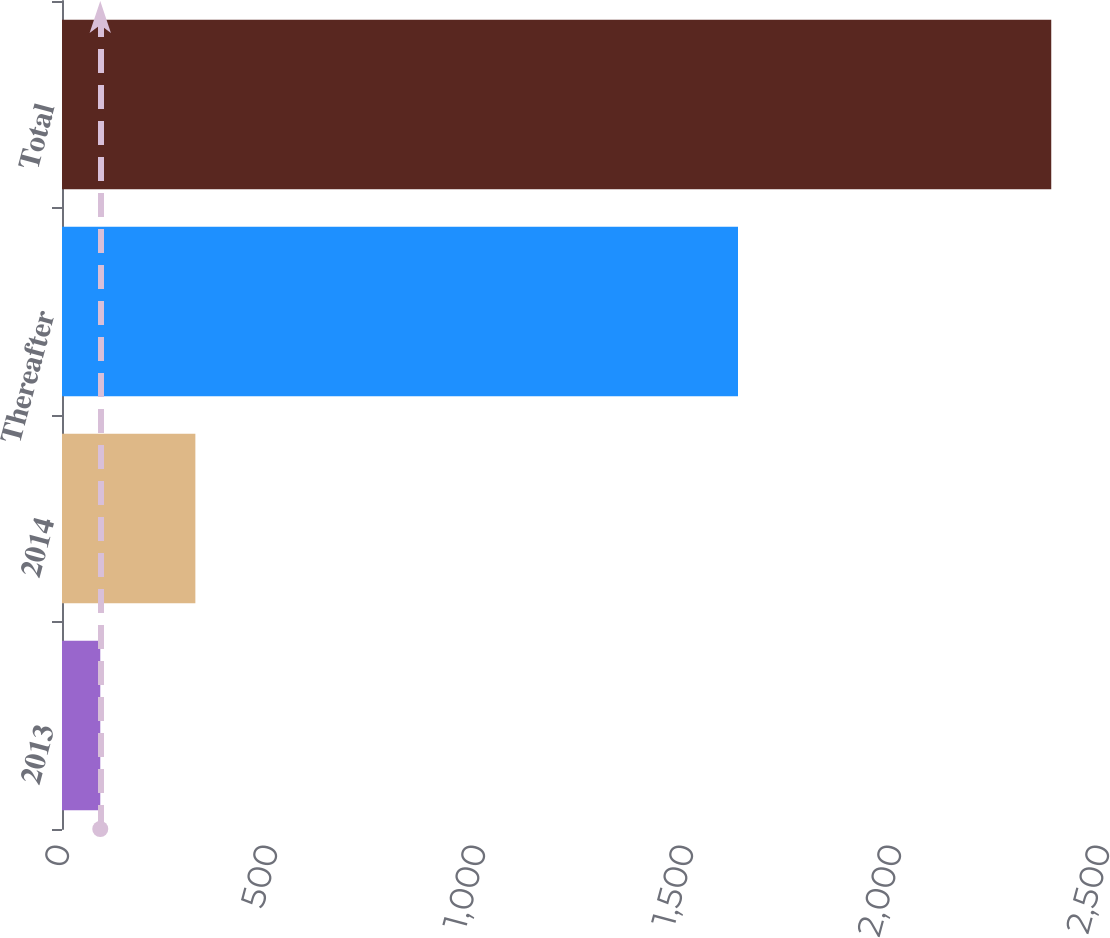Convert chart. <chart><loc_0><loc_0><loc_500><loc_500><bar_chart><fcel>2013<fcel>2014<fcel>Thereafter<fcel>Total<nl><fcel>92<fcel>320.6<fcel>1625<fcel>2378<nl></chart> 